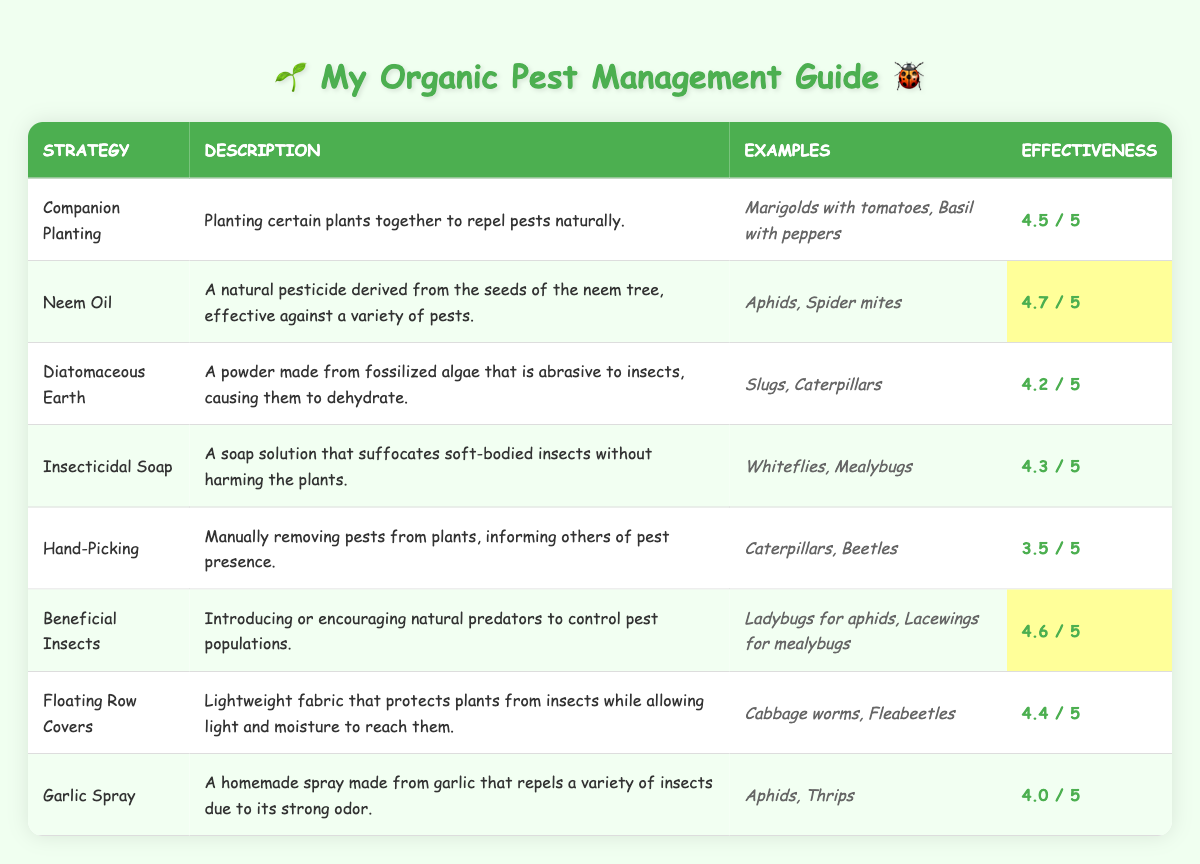What is the effectiveness rating of Neem Oil? According to the table, the effectiveness rating for Neem Oil is highlighted. By checking the relevant row in the table, it shows that Neem Oil has an effectiveness rating of 4.7.
Answer: 4.7 Which strategy has the lowest effectiveness rating? By reviewing the effectiveness ratings in the table, Hand-Picking has the lowest rating of 3.5. The other strategies all have higher ratings than this.
Answer: Hand-Picking How many strategies have an effectiveness rating of 4.5 or higher? I will count the strategies in the table with effectiveness ratings of 4.5 or higher. The strategies that qualify are Companion Planting, Neem Oil, Beneficial Insects, Floating Row Covers, and Insecticidal Soap, totaling 5 strategies.
Answer: 5 Is Garlic Spray effective against Spider mites? The table does not list Spider mites as an example for Garlic Spray; it lists Aphids and Thrips. So, Garlic Spray is not effective against Spider mites.
Answer: No Which strategy has a higher effectiveness rating: Insecticidal Soap or Diatomaceous Earth? I will compare the effectiveness ratings: Insecticidal Soap has a rating of 4.3 and Diatomaceous Earth has 4.2. Since 4.3 is greater than 4.2, Insecticidal Soap is more effective.
Answer: Insecticidal Soap What is the average effectiveness rating of all strategies listed? To find the average, I will sum the effectiveness ratings (4.5 + 4.7 + 4.2 + 4.3 + 3.5 + 4.6 + 4.4 + 4.0 = 34.2) and divide by the number of strategies (8). Therefore, the average effectiveness is 34.2 / 8 = 4.275.
Answer: 4.275 Are there any strategies with the same effectiveness rating? After reviewing the table, all strategies have distinct effectiveness ratings except for the effectiveness ratings which are not shared among any strategies.
Answer: No Which examples are listed for the strategy with the second highest effectiveness? The strategy with the second highest effectiveness rating of 4.6 is "Beneficial Insects." The table lists "Ladybugs for aphids" and "Lacewings for mealybugs" as the relevant examples.
Answer: Ladybugs for aphids, Lacewings for mealybugs What is the difference in effectiveness rating between Companion Planting and Hand-Picking? Companion Planting has an effectiveness rating of 4.5, and Hand-Picking has an effectiveness rating of 3.5. To find the difference, I subtract 3.5 from 4.5, giving me a difference of 1.0.
Answer: 1.0 Which pest can be managed using both Neem Oil and Garlic Spray? By looking at the examples for both strategies, Neem Oil can manage "Aphids," and Garlic Spray can also manage "Aphids." So, Aphids can be managed by both strategies.
Answer: Aphids 